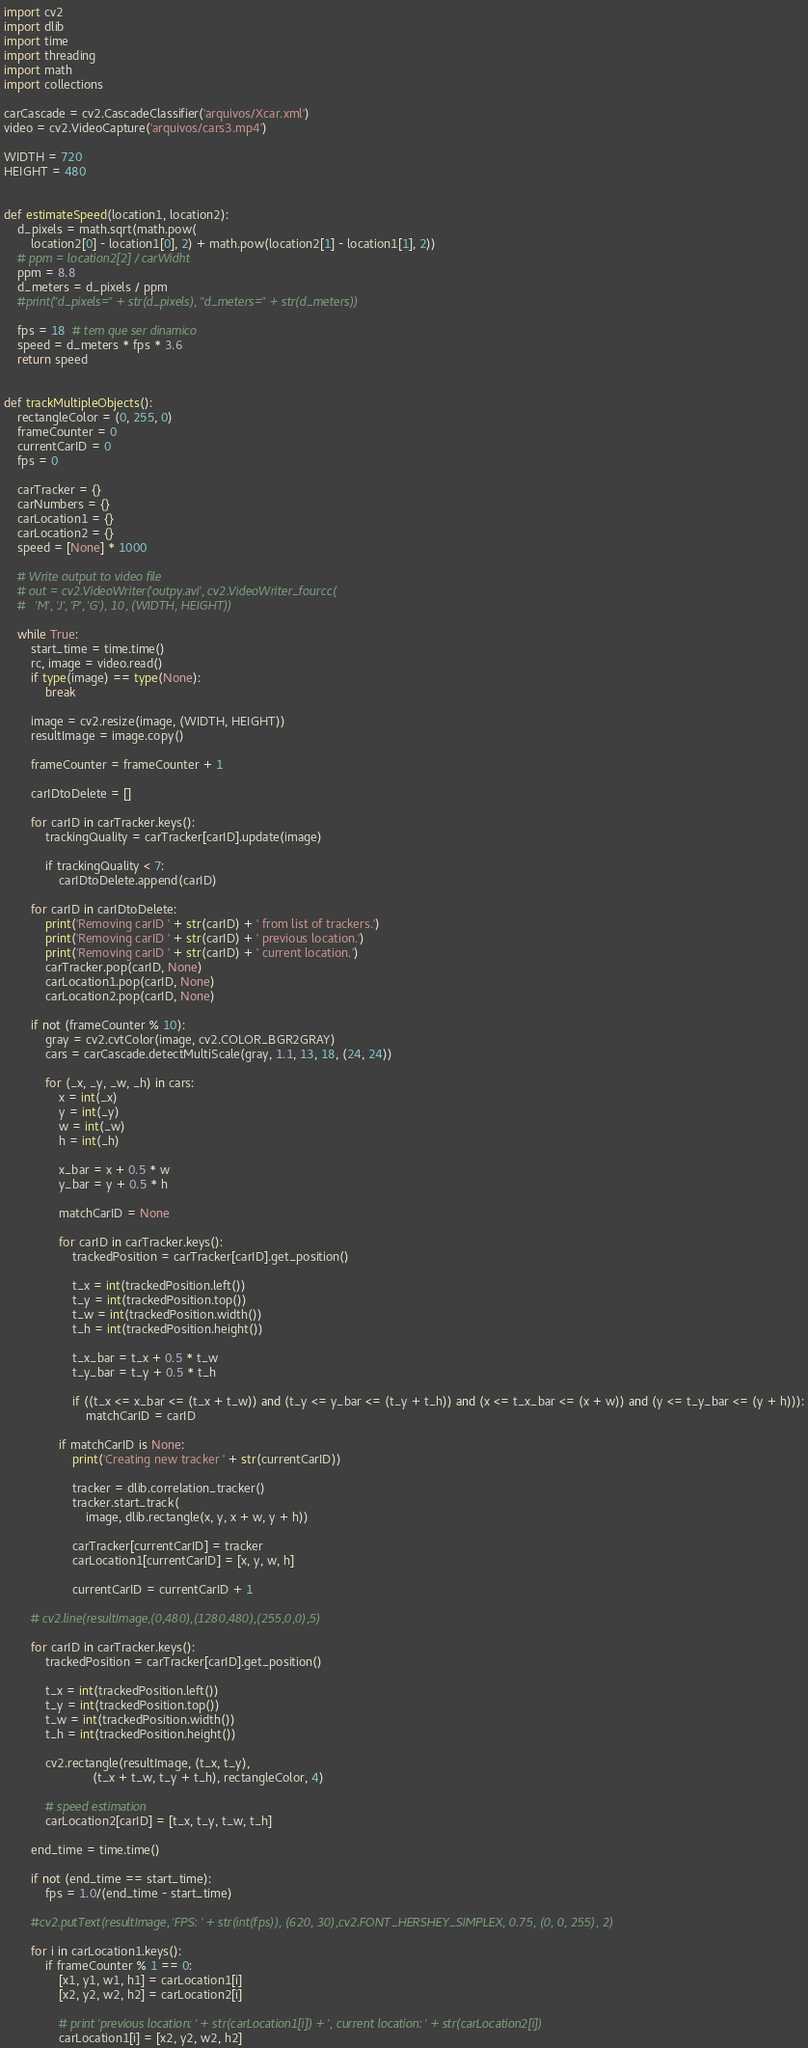Convert code to text. <code><loc_0><loc_0><loc_500><loc_500><_Python_>import cv2
import dlib
import time
import threading
import math
import collections

carCascade = cv2.CascadeClassifier('arquivos/Xcar.xml')
video = cv2.VideoCapture('arquivos/cars3.mp4')

WIDTH = 720
HEIGHT = 480


def estimateSpeed(location1, location2):
    d_pixels = math.sqrt(math.pow(
        location2[0] - location1[0], 2) + math.pow(location2[1] - location1[1], 2))
    # ppm = location2[2] / carWidht
    ppm = 8.8
    d_meters = d_pixels / ppm
    #print("d_pixels=" + str(d_pixels), "d_meters=" + str(d_meters))

    fps = 18  # tem que ser dinamico
    speed = d_meters * fps * 3.6
    return speed


def trackMultipleObjects():
    rectangleColor = (0, 255, 0)
    frameCounter = 0
    currentCarID = 0
    fps = 0

    carTracker = {}
    carNumbers = {}
    carLocation1 = {}
    carLocation2 = {}
    speed = [None] * 1000

    # Write output to video file
    # out = cv2.VideoWriter('outpy.avi', cv2.VideoWriter_fourcc(
    #   'M', 'J', 'P', 'G'), 10, (WIDTH, HEIGHT))

    while True:
        start_time = time.time()
        rc, image = video.read()
        if type(image) == type(None):
            break

        image = cv2.resize(image, (WIDTH, HEIGHT))
        resultImage = image.copy()

        frameCounter = frameCounter + 1

        carIDtoDelete = []

        for carID in carTracker.keys():
            trackingQuality = carTracker[carID].update(image)

            if trackingQuality < 7:
                carIDtoDelete.append(carID)

        for carID in carIDtoDelete:
            print('Removing carID ' + str(carID) + ' from list of trackers.')
            print('Removing carID ' + str(carID) + ' previous location.')
            print('Removing carID ' + str(carID) + ' current location.')
            carTracker.pop(carID, None)
            carLocation1.pop(carID, None)
            carLocation2.pop(carID, None)

        if not (frameCounter % 10):
            gray = cv2.cvtColor(image, cv2.COLOR_BGR2GRAY)
            cars = carCascade.detectMultiScale(gray, 1.1, 13, 18, (24, 24))

            for (_x, _y, _w, _h) in cars:
                x = int(_x)
                y = int(_y)
                w = int(_w)
                h = int(_h)

                x_bar = x + 0.5 * w
                y_bar = y + 0.5 * h

                matchCarID = None

                for carID in carTracker.keys():
                    trackedPosition = carTracker[carID].get_position()

                    t_x = int(trackedPosition.left())
                    t_y = int(trackedPosition.top())
                    t_w = int(trackedPosition.width())
                    t_h = int(trackedPosition.height())

                    t_x_bar = t_x + 0.5 * t_w
                    t_y_bar = t_y + 0.5 * t_h

                    if ((t_x <= x_bar <= (t_x + t_w)) and (t_y <= y_bar <= (t_y + t_h)) and (x <= t_x_bar <= (x + w)) and (y <= t_y_bar <= (y + h))):
                        matchCarID = carID

                if matchCarID is None:
                    print('Creating new tracker ' + str(currentCarID))

                    tracker = dlib.correlation_tracker()
                    tracker.start_track(
                        image, dlib.rectangle(x, y, x + w, y + h))

                    carTracker[currentCarID] = tracker
                    carLocation1[currentCarID] = [x, y, w, h]

                    currentCarID = currentCarID + 1

        # cv2.line(resultImage,(0,480),(1280,480),(255,0,0),5)

        for carID in carTracker.keys():
            trackedPosition = carTracker[carID].get_position()

            t_x = int(trackedPosition.left())
            t_y = int(trackedPosition.top())
            t_w = int(trackedPosition.width())
            t_h = int(trackedPosition.height())

            cv2.rectangle(resultImage, (t_x, t_y),
                          (t_x + t_w, t_y + t_h), rectangleColor, 4)

            # speed estimation
            carLocation2[carID] = [t_x, t_y, t_w, t_h]

        end_time = time.time()

        if not (end_time == start_time):
            fps = 1.0/(end_time - start_time)

        #cv2.putText(resultImage, 'FPS: ' + str(int(fps)), (620, 30),cv2.FONT_HERSHEY_SIMPLEX, 0.75, (0, 0, 255), 2)

        for i in carLocation1.keys():
            if frameCounter % 1 == 0:
                [x1, y1, w1, h1] = carLocation1[i]
                [x2, y2, w2, h2] = carLocation2[i]

                # print 'previous location: ' + str(carLocation1[i]) + ', current location: ' + str(carLocation2[i])
                carLocation1[i] = [x2, y2, w2, h2]
</code> 